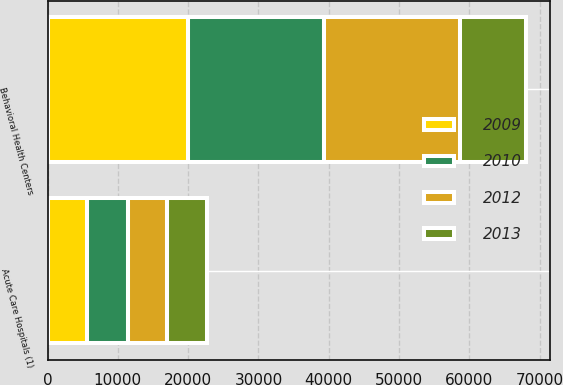Convert chart. <chart><loc_0><loc_0><loc_500><loc_500><stacked_bar_chart><ecel><fcel>Acute Care Hospitals (1)<fcel>Behavioral Health Centers<nl><fcel>2009<fcel>5652<fcel>19975<nl><fcel>2012<fcel>5682<fcel>19362<nl><fcel>2010<fcel>5726<fcel>19280<nl><fcel>2013<fcel>5689<fcel>9427<nl></chart> 